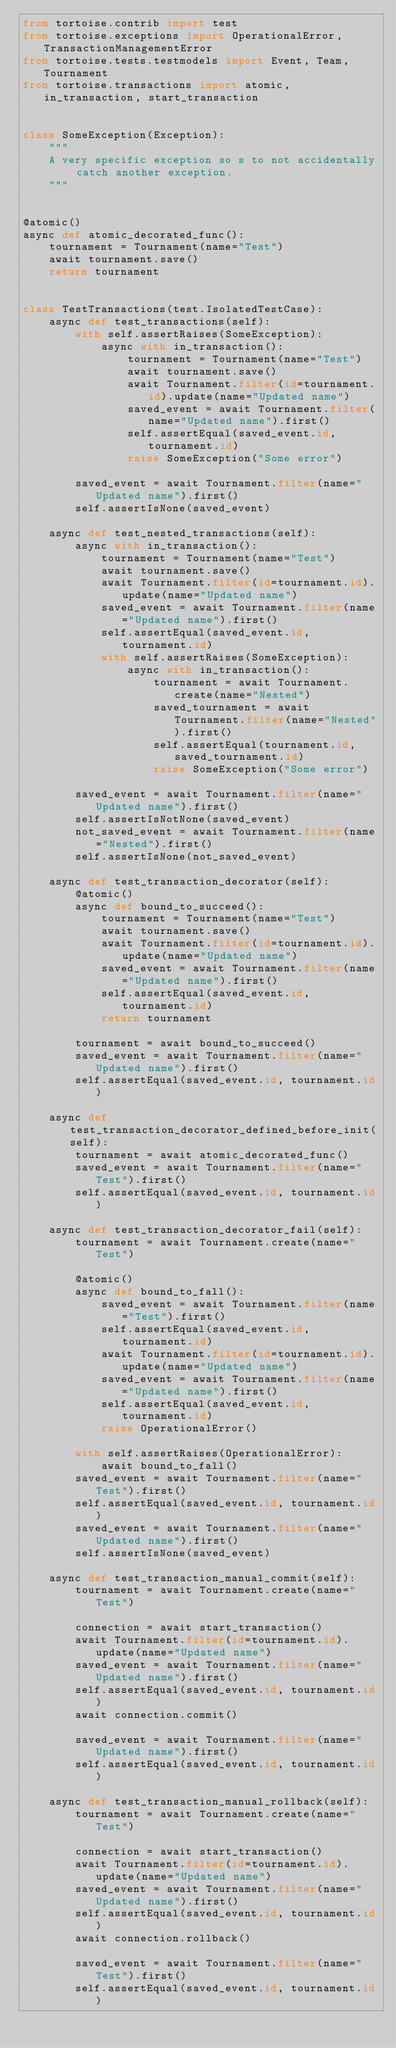Convert code to text. <code><loc_0><loc_0><loc_500><loc_500><_Python_>from tortoise.contrib import test
from tortoise.exceptions import OperationalError, TransactionManagementError
from tortoise.tests.testmodels import Event, Team, Tournament
from tortoise.transactions import atomic, in_transaction, start_transaction


class SomeException(Exception):
    """
    A very specific exception so s to not accidentally catch another exception.
    """


@atomic()
async def atomic_decorated_func():
    tournament = Tournament(name="Test")
    await tournament.save()
    return tournament


class TestTransactions(test.IsolatedTestCase):
    async def test_transactions(self):
        with self.assertRaises(SomeException):
            async with in_transaction():
                tournament = Tournament(name="Test")
                await tournament.save()
                await Tournament.filter(id=tournament.id).update(name="Updated name")
                saved_event = await Tournament.filter(name="Updated name").first()
                self.assertEqual(saved_event.id, tournament.id)
                raise SomeException("Some error")

        saved_event = await Tournament.filter(name="Updated name").first()
        self.assertIsNone(saved_event)

    async def test_nested_transactions(self):
        async with in_transaction():
            tournament = Tournament(name="Test")
            await tournament.save()
            await Tournament.filter(id=tournament.id).update(name="Updated name")
            saved_event = await Tournament.filter(name="Updated name").first()
            self.assertEqual(saved_event.id, tournament.id)
            with self.assertRaises(SomeException):
                async with in_transaction():
                    tournament = await Tournament.create(name="Nested")
                    saved_tournament = await Tournament.filter(name="Nested").first()
                    self.assertEqual(tournament.id, saved_tournament.id)
                    raise SomeException("Some error")

        saved_event = await Tournament.filter(name="Updated name").first()
        self.assertIsNotNone(saved_event)
        not_saved_event = await Tournament.filter(name="Nested").first()
        self.assertIsNone(not_saved_event)

    async def test_transaction_decorator(self):
        @atomic()
        async def bound_to_succeed():
            tournament = Tournament(name="Test")
            await tournament.save()
            await Tournament.filter(id=tournament.id).update(name="Updated name")
            saved_event = await Tournament.filter(name="Updated name").first()
            self.assertEqual(saved_event.id, tournament.id)
            return tournament

        tournament = await bound_to_succeed()
        saved_event = await Tournament.filter(name="Updated name").first()
        self.assertEqual(saved_event.id, tournament.id)

    async def test_transaction_decorator_defined_before_init(self):
        tournament = await atomic_decorated_func()
        saved_event = await Tournament.filter(name="Test").first()
        self.assertEqual(saved_event.id, tournament.id)

    async def test_transaction_decorator_fail(self):
        tournament = await Tournament.create(name="Test")

        @atomic()
        async def bound_to_fall():
            saved_event = await Tournament.filter(name="Test").first()
            self.assertEqual(saved_event.id, tournament.id)
            await Tournament.filter(id=tournament.id).update(name="Updated name")
            saved_event = await Tournament.filter(name="Updated name").first()
            self.assertEqual(saved_event.id, tournament.id)
            raise OperationalError()

        with self.assertRaises(OperationalError):
            await bound_to_fall()
        saved_event = await Tournament.filter(name="Test").first()
        self.assertEqual(saved_event.id, tournament.id)
        saved_event = await Tournament.filter(name="Updated name").first()
        self.assertIsNone(saved_event)

    async def test_transaction_manual_commit(self):
        tournament = await Tournament.create(name="Test")

        connection = await start_transaction()
        await Tournament.filter(id=tournament.id).update(name="Updated name")
        saved_event = await Tournament.filter(name="Updated name").first()
        self.assertEqual(saved_event.id, tournament.id)
        await connection.commit()

        saved_event = await Tournament.filter(name="Updated name").first()
        self.assertEqual(saved_event.id, tournament.id)

    async def test_transaction_manual_rollback(self):
        tournament = await Tournament.create(name="Test")

        connection = await start_transaction()
        await Tournament.filter(id=tournament.id).update(name="Updated name")
        saved_event = await Tournament.filter(name="Updated name").first()
        self.assertEqual(saved_event.id, tournament.id)
        await connection.rollback()

        saved_event = await Tournament.filter(name="Test").first()
        self.assertEqual(saved_event.id, tournament.id)</code> 